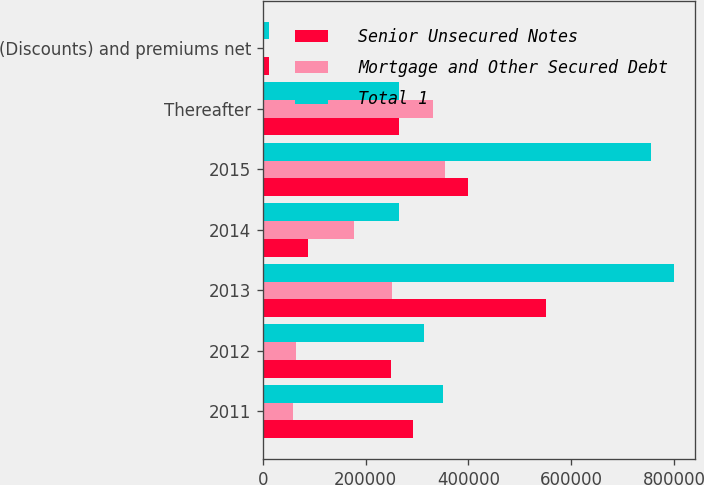<chart> <loc_0><loc_0><loc_500><loc_500><stacked_bar_chart><ecel><fcel>2011<fcel>2012<fcel>2013<fcel>2014<fcel>2015<fcel>Thereafter<fcel>(Discounts) and premiums net<nl><fcel>Senior Unsecured Notes<fcel>292265<fcel>250000<fcel>550000<fcel>87000<fcel>400000<fcel>264809<fcel>10886<nl><fcel>Mortgage and Other Secured Debt<fcel>57571<fcel>64103<fcel>250741<fcel>177809<fcel>355080<fcel>331748<fcel>1273<nl><fcel>Total 1<fcel>349836<fcel>314103<fcel>800741<fcel>264809<fcel>755080<fcel>264809<fcel>12159<nl></chart> 